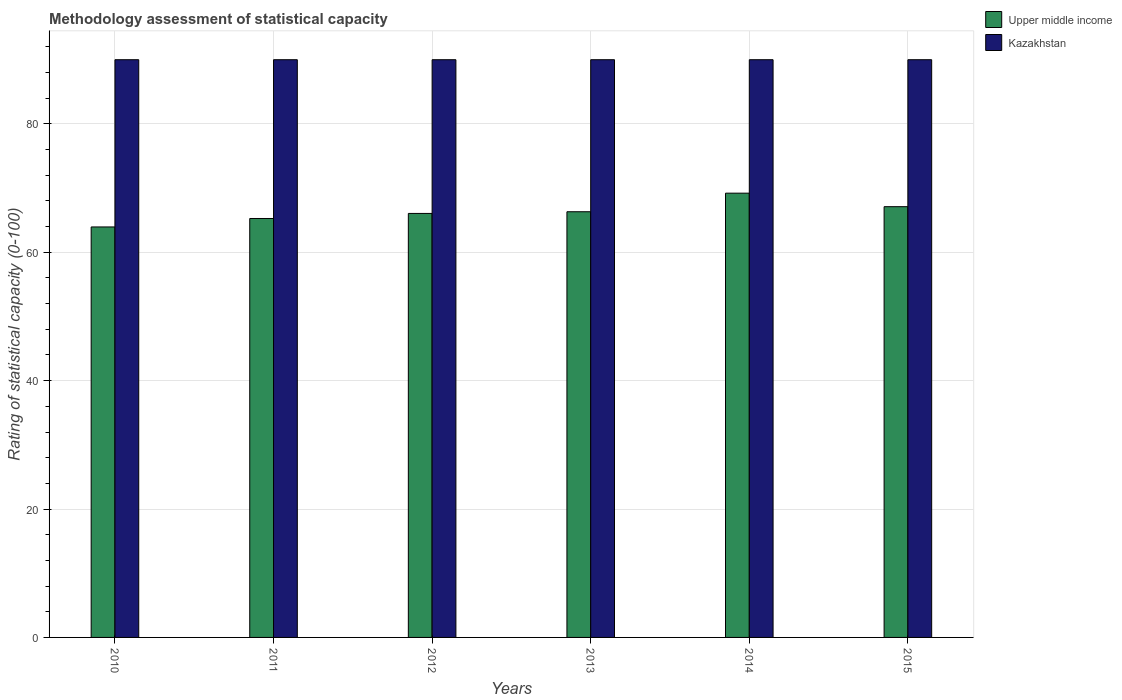How many different coloured bars are there?
Your answer should be very brief. 2. How many groups of bars are there?
Keep it short and to the point. 6. Are the number of bars per tick equal to the number of legend labels?
Your answer should be very brief. Yes. Are the number of bars on each tick of the X-axis equal?
Your answer should be compact. Yes. What is the label of the 4th group of bars from the left?
Your response must be concise. 2013. In how many cases, is the number of bars for a given year not equal to the number of legend labels?
Keep it short and to the point. 0. What is the rating of statistical capacity in Kazakhstan in 2011?
Provide a short and direct response. 90. Across all years, what is the maximum rating of statistical capacity in Upper middle income?
Give a very brief answer. 69.21. Across all years, what is the minimum rating of statistical capacity in Upper middle income?
Offer a very short reply. 63.95. What is the total rating of statistical capacity in Upper middle income in the graph?
Your answer should be compact. 397.89. What is the difference between the rating of statistical capacity in Upper middle income in 2011 and that in 2014?
Your response must be concise. -3.95. What is the difference between the rating of statistical capacity in Kazakhstan in 2011 and the rating of statistical capacity in Upper middle income in 2014?
Offer a terse response. 20.79. What is the average rating of statistical capacity in Kazakhstan per year?
Your answer should be very brief. 90. In the year 2014, what is the difference between the rating of statistical capacity in Kazakhstan and rating of statistical capacity in Upper middle income?
Offer a terse response. 20.79. What is the ratio of the rating of statistical capacity in Upper middle income in 2010 to that in 2013?
Your answer should be very brief. 0.96. Is the difference between the rating of statistical capacity in Kazakhstan in 2013 and 2015 greater than the difference between the rating of statistical capacity in Upper middle income in 2013 and 2015?
Provide a short and direct response. Yes. What is the difference between the highest and the second highest rating of statistical capacity in Upper middle income?
Give a very brief answer. 2.11. What does the 1st bar from the left in 2011 represents?
Offer a terse response. Upper middle income. What does the 2nd bar from the right in 2012 represents?
Provide a short and direct response. Upper middle income. What is the difference between two consecutive major ticks on the Y-axis?
Your response must be concise. 20. Are the values on the major ticks of Y-axis written in scientific E-notation?
Ensure brevity in your answer.  No. Where does the legend appear in the graph?
Offer a very short reply. Top right. How many legend labels are there?
Offer a very short reply. 2. How are the legend labels stacked?
Ensure brevity in your answer.  Vertical. What is the title of the graph?
Ensure brevity in your answer.  Methodology assessment of statistical capacity. What is the label or title of the Y-axis?
Provide a short and direct response. Rating of statistical capacity (0-100). What is the Rating of statistical capacity (0-100) of Upper middle income in 2010?
Make the answer very short. 63.95. What is the Rating of statistical capacity (0-100) of Upper middle income in 2011?
Your response must be concise. 65.26. What is the Rating of statistical capacity (0-100) in Kazakhstan in 2011?
Provide a short and direct response. 90. What is the Rating of statistical capacity (0-100) in Upper middle income in 2012?
Keep it short and to the point. 66.05. What is the Rating of statistical capacity (0-100) in Kazakhstan in 2012?
Keep it short and to the point. 90. What is the Rating of statistical capacity (0-100) in Upper middle income in 2013?
Give a very brief answer. 66.32. What is the Rating of statistical capacity (0-100) of Kazakhstan in 2013?
Offer a terse response. 90. What is the Rating of statistical capacity (0-100) in Upper middle income in 2014?
Ensure brevity in your answer.  69.21. What is the Rating of statistical capacity (0-100) of Kazakhstan in 2014?
Offer a very short reply. 90. What is the Rating of statistical capacity (0-100) in Upper middle income in 2015?
Your response must be concise. 67.11. Across all years, what is the maximum Rating of statistical capacity (0-100) in Upper middle income?
Make the answer very short. 69.21. Across all years, what is the minimum Rating of statistical capacity (0-100) in Upper middle income?
Your answer should be compact. 63.95. Across all years, what is the minimum Rating of statistical capacity (0-100) of Kazakhstan?
Ensure brevity in your answer.  90. What is the total Rating of statistical capacity (0-100) of Upper middle income in the graph?
Keep it short and to the point. 397.89. What is the total Rating of statistical capacity (0-100) of Kazakhstan in the graph?
Offer a very short reply. 540. What is the difference between the Rating of statistical capacity (0-100) in Upper middle income in 2010 and that in 2011?
Ensure brevity in your answer.  -1.32. What is the difference between the Rating of statistical capacity (0-100) of Kazakhstan in 2010 and that in 2011?
Give a very brief answer. 0. What is the difference between the Rating of statistical capacity (0-100) in Upper middle income in 2010 and that in 2012?
Ensure brevity in your answer.  -2.11. What is the difference between the Rating of statistical capacity (0-100) of Upper middle income in 2010 and that in 2013?
Your response must be concise. -2.37. What is the difference between the Rating of statistical capacity (0-100) in Upper middle income in 2010 and that in 2014?
Your answer should be very brief. -5.26. What is the difference between the Rating of statistical capacity (0-100) of Kazakhstan in 2010 and that in 2014?
Provide a short and direct response. 0. What is the difference between the Rating of statistical capacity (0-100) in Upper middle income in 2010 and that in 2015?
Ensure brevity in your answer.  -3.16. What is the difference between the Rating of statistical capacity (0-100) in Upper middle income in 2011 and that in 2012?
Provide a succinct answer. -0.79. What is the difference between the Rating of statistical capacity (0-100) of Kazakhstan in 2011 and that in 2012?
Offer a very short reply. 0. What is the difference between the Rating of statistical capacity (0-100) of Upper middle income in 2011 and that in 2013?
Your response must be concise. -1.05. What is the difference between the Rating of statistical capacity (0-100) of Kazakhstan in 2011 and that in 2013?
Offer a very short reply. 0. What is the difference between the Rating of statistical capacity (0-100) of Upper middle income in 2011 and that in 2014?
Your answer should be compact. -3.95. What is the difference between the Rating of statistical capacity (0-100) in Upper middle income in 2011 and that in 2015?
Provide a short and direct response. -1.84. What is the difference between the Rating of statistical capacity (0-100) of Upper middle income in 2012 and that in 2013?
Give a very brief answer. -0.26. What is the difference between the Rating of statistical capacity (0-100) of Kazakhstan in 2012 and that in 2013?
Provide a short and direct response. 0. What is the difference between the Rating of statistical capacity (0-100) of Upper middle income in 2012 and that in 2014?
Provide a succinct answer. -3.16. What is the difference between the Rating of statistical capacity (0-100) in Upper middle income in 2012 and that in 2015?
Ensure brevity in your answer.  -1.05. What is the difference between the Rating of statistical capacity (0-100) of Kazakhstan in 2012 and that in 2015?
Provide a succinct answer. 0. What is the difference between the Rating of statistical capacity (0-100) of Upper middle income in 2013 and that in 2014?
Make the answer very short. -2.89. What is the difference between the Rating of statistical capacity (0-100) of Upper middle income in 2013 and that in 2015?
Keep it short and to the point. -0.79. What is the difference between the Rating of statistical capacity (0-100) of Kazakhstan in 2013 and that in 2015?
Your response must be concise. 0. What is the difference between the Rating of statistical capacity (0-100) of Upper middle income in 2014 and that in 2015?
Give a very brief answer. 2.11. What is the difference between the Rating of statistical capacity (0-100) of Kazakhstan in 2014 and that in 2015?
Your answer should be very brief. 0. What is the difference between the Rating of statistical capacity (0-100) of Upper middle income in 2010 and the Rating of statistical capacity (0-100) of Kazakhstan in 2011?
Your answer should be very brief. -26.05. What is the difference between the Rating of statistical capacity (0-100) of Upper middle income in 2010 and the Rating of statistical capacity (0-100) of Kazakhstan in 2012?
Ensure brevity in your answer.  -26.05. What is the difference between the Rating of statistical capacity (0-100) in Upper middle income in 2010 and the Rating of statistical capacity (0-100) in Kazakhstan in 2013?
Offer a terse response. -26.05. What is the difference between the Rating of statistical capacity (0-100) in Upper middle income in 2010 and the Rating of statistical capacity (0-100) in Kazakhstan in 2014?
Keep it short and to the point. -26.05. What is the difference between the Rating of statistical capacity (0-100) in Upper middle income in 2010 and the Rating of statistical capacity (0-100) in Kazakhstan in 2015?
Give a very brief answer. -26.05. What is the difference between the Rating of statistical capacity (0-100) in Upper middle income in 2011 and the Rating of statistical capacity (0-100) in Kazakhstan in 2012?
Give a very brief answer. -24.74. What is the difference between the Rating of statistical capacity (0-100) in Upper middle income in 2011 and the Rating of statistical capacity (0-100) in Kazakhstan in 2013?
Provide a short and direct response. -24.74. What is the difference between the Rating of statistical capacity (0-100) in Upper middle income in 2011 and the Rating of statistical capacity (0-100) in Kazakhstan in 2014?
Offer a very short reply. -24.74. What is the difference between the Rating of statistical capacity (0-100) in Upper middle income in 2011 and the Rating of statistical capacity (0-100) in Kazakhstan in 2015?
Make the answer very short. -24.74. What is the difference between the Rating of statistical capacity (0-100) in Upper middle income in 2012 and the Rating of statistical capacity (0-100) in Kazakhstan in 2013?
Make the answer very short. -23.95. What is the difference between the Rating of statistical capacity (0-100) of Upper middle income in 2012 and the Rating of statistical capacity (0-100) of Kazakhstan in 2014?
Give a very brief answer. -23.95. What is the difference between the Rating of statistical capacity (0-100) of Upper middle income in 2012 and the Rating of statistical capacity (0-100) of Kazakhstan in 2015?
Your answer should be very brief. -23.95. What is the difference between the Rating of statistical capacity (0-100) of Upper middle income in 2013 and the Rating of statistical capacity (0-100) of Kazakhstan in 2014?
Keep it short and to the point. -23.68. What is the difference between the Rating of statistical capacity (0-100) in Upper middle income in 2013 and the Rating of statistical capacity (0-100) in Kazakhstan in 2015?
Make the answer very short. -23.68. What is the difference between the Rating of statistical capacity (0-100) of Upper middle income in 2014 and the Rating of statistical capacity (0-100) of Kazakhstan in 2015?
Your answer should be very brief. -20.79. What is the average Rating of statistical capacity (0-100) in Upper middle income per year?
Your answer should be very brief. 66.32. What is the average Rating of statistical capacity (0-100) of Kazakhstan per year?
Make the answer very short. 90. In the year 2010, what is the difference between the Rating of statistical capacity (0-100) of Upper middle income and Rating of statistical capacity (0-100) of Kazakhstan?
Ensure brevity in your answer.  -26.05. In the year 2011, what is the difference between the Rating of statistical capacity (0-100) of Upper middle income and Rating of statistical capacity (0-100) of Kazakhstan?
Your answer should be very brief. -24.74. In the year 2012, what is the difference between the Rating of statistical capacity (0-100) of Upper middle income and Rating of statistical capacity (0-100) of Kazakhstan?
Your answer should be compact. -23.95. In the year 2013, what is the difference between the Rating of statistical capacity (0-100) of Upper middle income and Rating of statistical capacity (0-100) of Kazakhstan?
Your answer should be very brief. -23.68. In the year 2014, what is the difference between the Rating of statistical capacity (0-100) in Upper middle income and Rating of statistical capacity (0-100) in Kazakhstan?
Provide a succinct answer. -20.79. In the year 2015, what is the difference between the Rating of statistical capacity (0-100) in Upper middle income and Rating of statistical capacity (0-100) in Kazakhstan?
Provide a short and direct response. -22.89. What is the ratio of the Rating of statistical capacity (0-100) of Upper middle income in 2010 to that in 2011?
Give a very brief answer. 0.98. What is the ratio of the Rating of statistical capacity (0-100) in Upper middle income in 2010 to that in 2012?
Give a very brief answer. 0.97. What is the ratio of the Rating of statistical capacity (0-100) in Upper middle income in 2010 to that in 2014?
Give a very brief answer. 0.92. What is the ratio of the Rating of statistical capacity (0-100) in Kazakhstan in 2010 to that in 2014?
Offer a very short reply. 1. What is the ratio of the Rating of statistical capacity (0-100) of Upper middle income in 2010 to that in 2015?
Provide a short and direct response. 0.95. What is the ratio of the Rating of statistical capacity (0-100) in Kazakhstan in 2010 to that in 2015?
Give a very brief answer. 1. What is the ratio of the Rating of statistical capacity (0-100) of Upper middle income in 2011 to that in 2012?
Ensure brevity in your answer.  0.99. What is the ratio of the Rating of statistical capacity (0-100) in Upper middle income in 2011 to that in 2013?
Provide a succinct answer. 0.98. What is the ratio of the Rating of statistical capacity (0-100) in Kazakhstan in 2011 to that in 2013?
Offer a very short reply. 1. What is the ratio of the Rating of statistical capacity (0-100) of Upper middle income in 2011 to that in 2014?
Offer a terse response. 0.94. What is the ratio of the Rating of statistical capacity (0-100) of Upper middle income in 2011 to that in 2015?
Offer a very short reply. 0.97. What is the ratio of the Rating of statistical capacity (0-100) of Kazakhstan in 2011 to that in 2015?
Give a very brief answer. 1. What is the ratio of the Rating of statistical capacity (0-100) of Upper middle income in 2012 to that in 2013?
Keep it short and to the point. 1. What is the ratio of the Rating of statistical capacity (0-100) of Kazakhstan in 2012 to that in 2013?
Make the answer very short. 1. What is the ratio of the Rating of statistical capacity (0-100) in Upper middle income in 2012 to that in 2014?
Provide a succinct answer. 0.95. What is the ratio of the Rating of statistical capacity (0-100) in Upper middle income in 2012 to that in 2015?
Give a very brief answer. 0.98. What is the ratio of the Rating of statistical capacity (0-100) in Upper middle income in 2013 to that in 2014?
Your answer should be very brief. 0.96. What is the ratio of the Rating of statistical capacity (0-100) in Kazakhstan in 2013 to that in 2014?
Your response must be concise. 1. What is the ratio of the Rating of statistical capacity (0-100) of Upper middle income in 2013 to that in 2015?
Provide a short and direct response. 0.99. What is the ratio of the Rating of statistical capacity (0-100) in Kazakhstan in 2013 to that in 2015?
Give a very brief answer. 1. What is the ratio of the Rating of statistical capacity (0-100) in Upper middle income in 2014 to that in 2015?
Provide a succinct answer. 1.03. What is the ratio of the Rating of statistical capacity (0-100) of Kazakhstan in 2014 to that in 2015?
Give a very brief answer. 1. What is the difference between the highest and the second highest Rating of statistical capacity (0-100) of Upper middle income?
Provide a short and direct response. 2.11. What is the difference between the highest and the second highest Rating of statistical capacity (0-100) of Kazakhstan?
Give a very brief answer. 0. What is the difference between the highest and the lowest Rating of statistical capacity (0-100) of Upper middle income?
Your answer should be very brief. 5.26. 